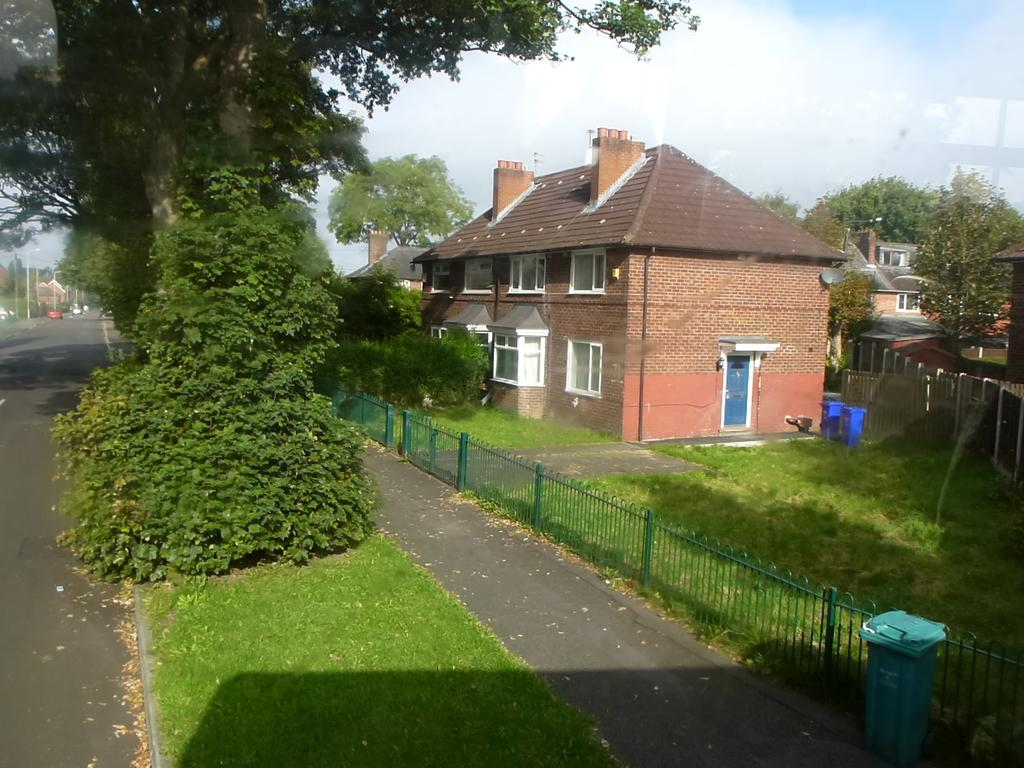What type of structures can be seen in the image? There are buildings in the image. What are the vertical objects with signs or lights on them in the image? Street poles are visible in the image. What are the tall, illuminated objects in the image? Street lights are present in the image. What can be used for disposing of waste in the image? Trash bins are in the image. What type of barriers can be seen in the image? Fences are visible in the image. What type of vegetation can be seen in the image? Bushes and trees are present in the image. What part of the natural environment is visible in the image? The sky is visible in the image. What can be seen in the sky in the image? Clouds are present in the sky. Can you tell me how many laborers are working on the buildings in the image? There is no indication of laborers or any construction work in progress in the image. What sound does the lift make as it moves up and down in the image? There is no lift present in the image. 